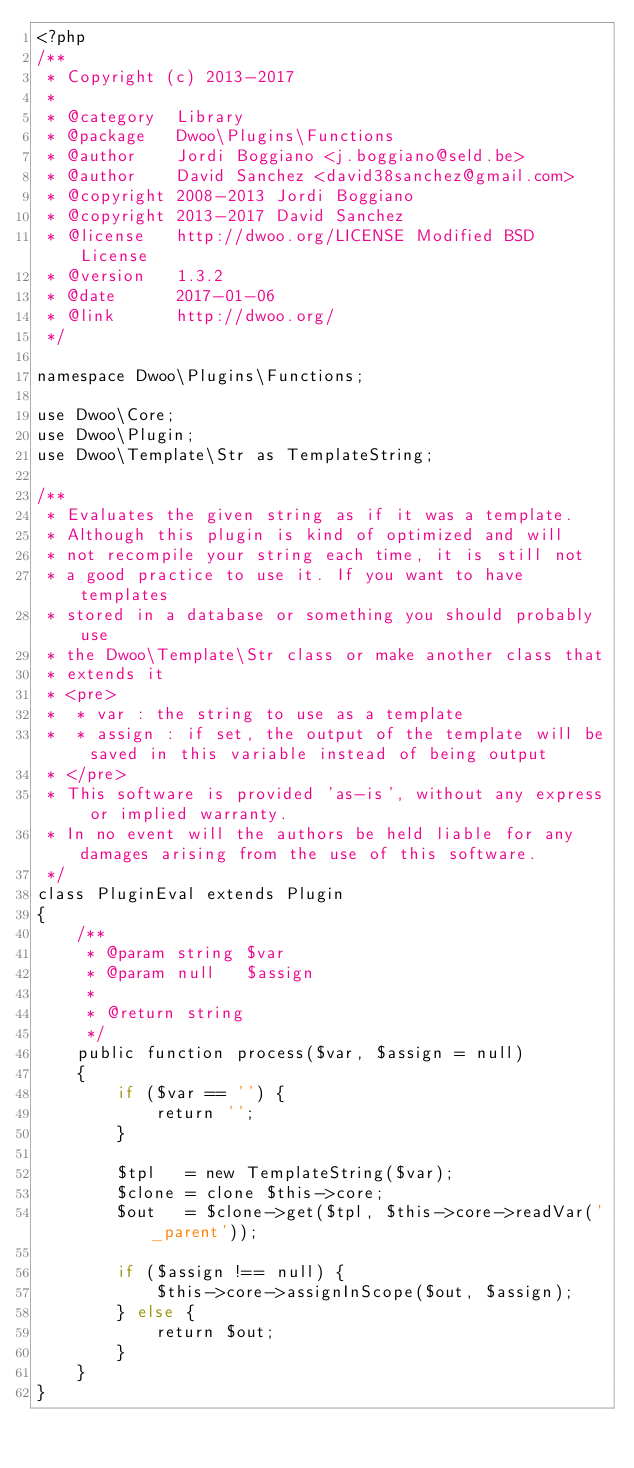Convert code to text. <code><loc_0><loc_0><loc_500><loc_500><_PHP_><?php
/**
 * Copyright (c) 2013-2017
 *
 * @category  Library
 * @package   Dwoo\Plugins\Functions
 * @author    Jordi Boggiano <j.boggiano@seld.be>
 * @author    David Sanchez <david38sanchez@gmail.com>
 * @copyright 2008-2013 Jordi Boggiano
 * @copyright 2013-2017 David Sanchez
 * @license   http://dwoo.org/LICENSE Modified BSD License
 * @version   1.3.2
 * @date      2017-01-06
 * @link      http://dwoo.org/
 */

namespace Dwoo\Plugins\Functions;

use Dwoo\Core;
use Dwoo\Plugin;
use Dwoo\Template\Str as TemplateString;

/**
 * Evaluates the given string as if it was a template.
 * Although this plugin is kind of optimized and will
 * not recompile your string each time, it is still not
 * a good practice to use it. If you want to have templates
 * stored in a database or something you should probably use
 * the Dwoo\Template\Str class or make another class that
 * extends it
 * <pre>
 *  * var : the string to use as a template
 *  * assign : if set, the output of the template will be saved in this variable instead of being output
 * </pre>
 * This software is provided 'as-is', without any express or implied warranty.
 * In no event will the authors be held liable for any damages arising from the use of this software.
 */
class PluginEval extends Plugin
{
    /**
     * @param string $var
     * @param null   $assign
     *
     * @return string
     */
    public function process($var, $assign = null)
    {
        if ($var == '') {
            return '';
        }

        $tpl   = new TemplateString($var);
        $clone = clone $this->core;
        $out   = $clone->get($tpl, $this->core->readVar('_parent'));

        if ($assign !== null) {
            $this->core->assignInScope($out, $assign);
        } else {
            return $out;
        }
    }
}</code> 